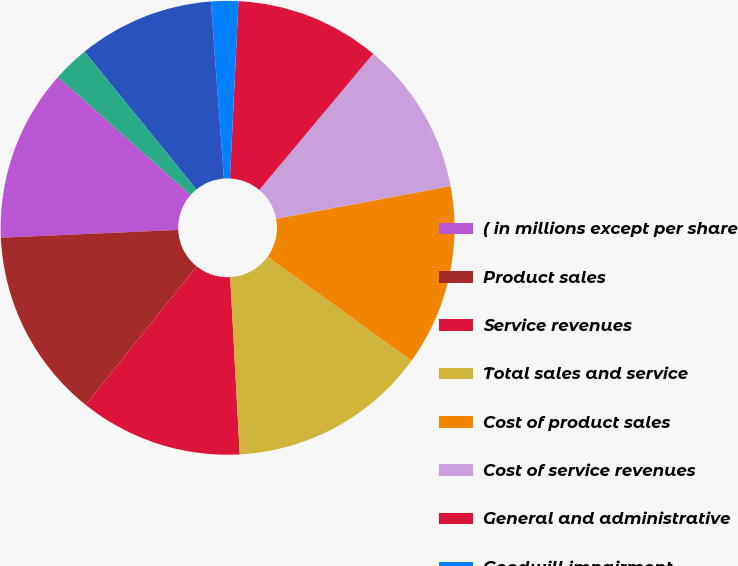Convert chart. <chart><loc_0><loc_0><loc_500><loc_500><pie_chart><fcel>( in millions except per share<fcel>Product sales<fcel>Service revenues<fcel>Total sales and service<fcel>Cost of product sales<fcel>Cost of service revenues<fcel>General and administrative<fcel>Goodwill impairment<fcel>Operating income (loss)<fcel>Interest expense<nl><fcel>12.26%<fcel>13.55%<fcel>11.61%<fcel>14.19%<fcel>12.9%<fcel>10.97%<fcel>10.32%<fcel>1.94%<fcel>9.68%<fcel>2.58%<nl></chart> 